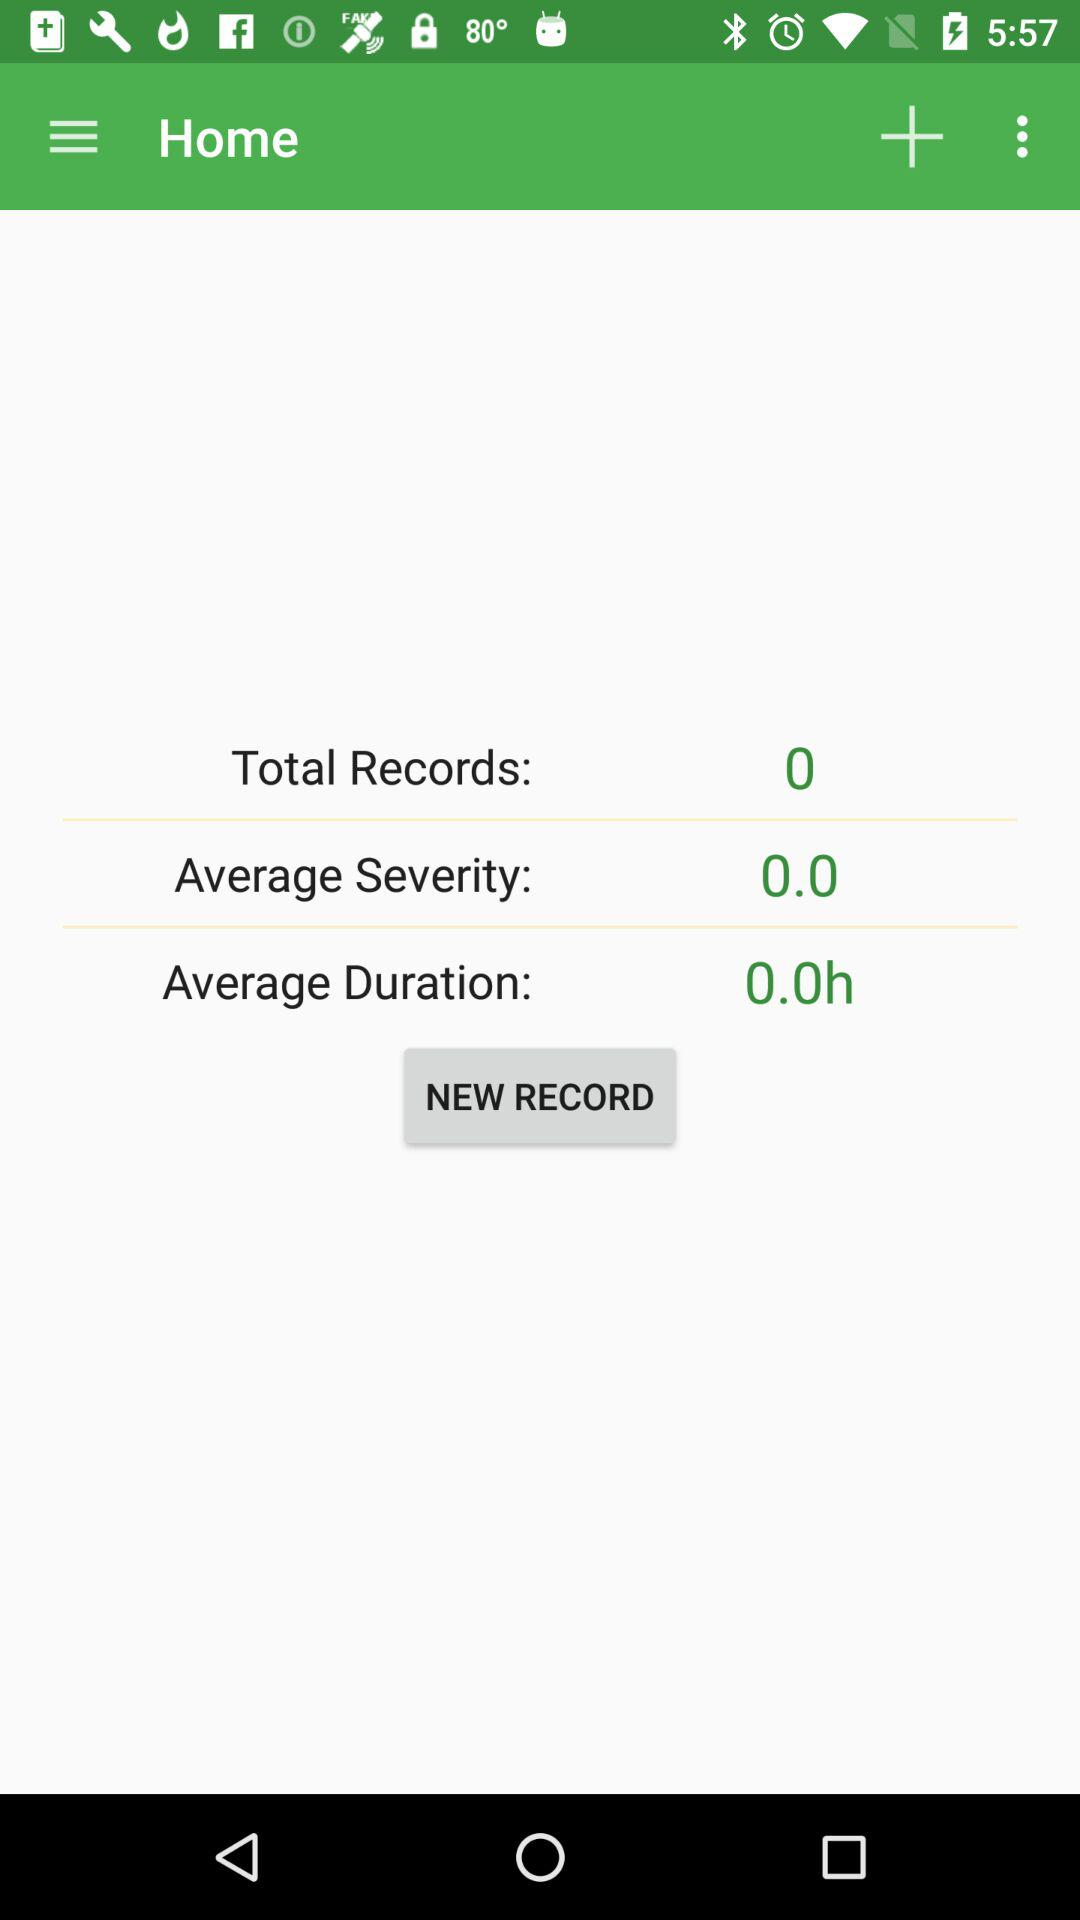What's the number of total records? There are 0 records. 